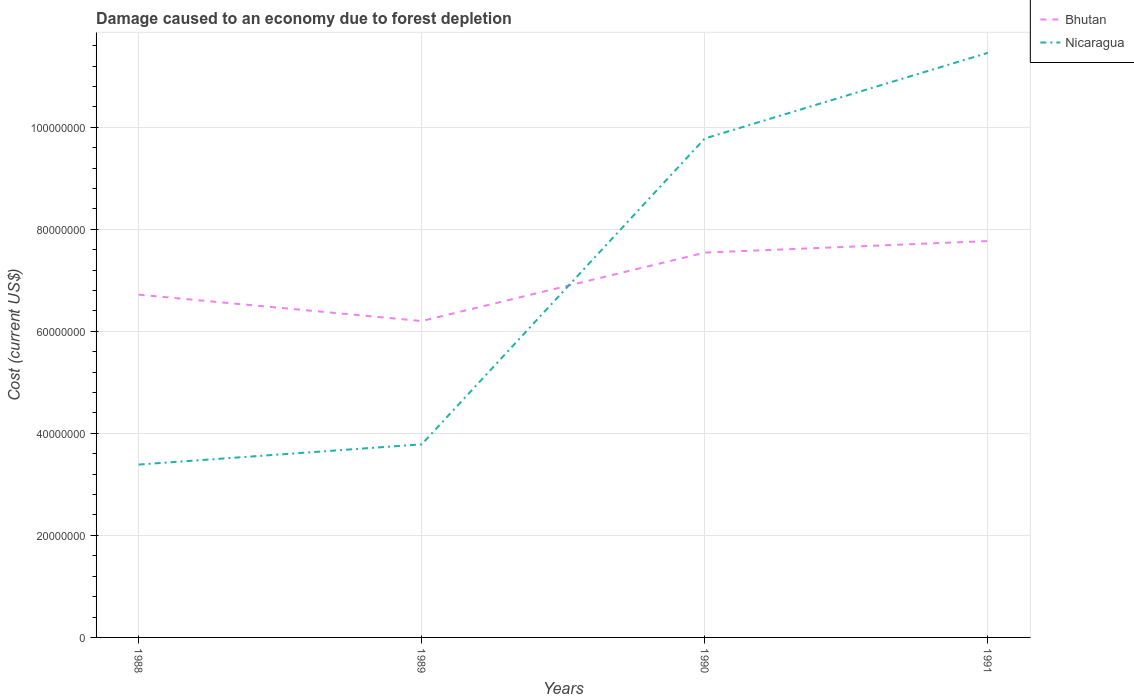How many different coloured lines are there?
Keep it short and to the point. 2. Does the line corresponding to Bhutan intersect with the line corresponding to Nicaragua?
Your response must be concise. Yes. Is the number of lines equal to the number of legend labels?
Your answer should be very brief. Yes. Across all years, what is the maximum cost of damage caused due to forest depletion in Nicaragua?
Offer a very short reply. 3.39e+07. In which year was the cost of damage caused due to forest depletion in Bhutan maximum?
Give a very brief answer. 1989. What is the total cost of damage caused due to forest depletion in Nicaragua in the graph?
Provide a short and direct response. -8.07e+07. What is the difference between the highest and the second highest cost of damage caused due to forest depletion in Nicaragua?
Your answer should be very brief. 8.07e+07. Where does the legend appear in the graph?
Provide a short and direct response. Top right. What is the title of the graph?
Give a very brief answer. Damage caused to an economy due to forest depletion. What is the label or title of the Y-axis?
Give a very brief answer. Cost (current US$). What is the Cost (current US$) of Bhutan in 1988?
Give a very brief answer. 6.72e+07. What is the Cost (current US$) in Nicaragua in 1988?
Your response must be concise. 3.39e+07. What is the Cost (current US$) of Bhutan in 1989?
Keep it short and to the point. 6.20e+07. What is the Cost (current US$) in Nicaragua in 1989?
Offer a very short reply. 3.79e+07. What is the Cost (current US$) in Bhutan in 1990?
Ensure brevity in your answer.  7.54e+07. What is the Cost (current US$) of Nicaragua in 1990?
Make the answer very short. 9.78e+07. What is the Cost (current US$) of Bhutan in 1991?
Your response must be concise. 7.77e+07. What is the Cost (current US$) of Nicaragua in 1991?
Keep it short and to the point. 1.15e+08. Across all years, what is the maximum Cost (current US$) in Bhutan?
Your answer should be compact. 7.77e+07. Across all years, what is the maximum Cost (current US$) in Nicaragua?
Your response must be concise. 1.15e+08. Across all years, what is the minimum Cost (current US$) in Bhutan?
Offer a terse response. 6.20e+07. Across all years, what is the minimum Cost (current US$) of Nicaragua?
Your answer should be very brief. 3.39e+07. What is the total Cost (current US$) of Bhutan in the graph?
Make the answer very short. 2.82e+08. What is the total Cost (current US$) in Nicaragua in the graph?
Make the answer very short. 2.84e+08. What is the difference between the Cost (current US$) in Bhutan in 1988 and that in 1989?
Offer a terse response. 5.17e+06. What is the difference between the Cost (current US$) in Nicaragua in 1988 and that in 1989?
Your response must be concise. -3.97e+06. What is the difference between the Cost (current US$) in Bhutan in 1988 and that in 1990?
Offer a terse response. -8.24e+06. What is the difference between the Cost (current US$) of Nicaragua in 1988 and that in 1990?
Your response must be concise. -6.39e+07. What is the difference between the Cost (current US$) in Bhutan in 1988 and that in 1991?
Offer a terse response. -1.05e+07. What is the difference between the Cost (current US$) in Nicaragua in 1988 and that in 1991?
Make the answer very short. -8.07e+07. What is the difference between the Cost (current US$) in Bhutan in 1989 and that in 1990?
Make the answer very short. -1.34e+07. What is the difference between the Cost (current US$) of Nicaragua in 1989 and that in 1990?
Make the answer very short. -5.99e+07. What is the difference between the Cost (current US$) of Bhutan in 1989 and that in 1991?
Ensure brevity in your answer.  -1.57e+07. What is the difference between the Cost (current US$) in Nicaragua in 1989 and that in 1991?
Keep it short and to the point. -7.67e+07. What is the difference between the Cost (current US$) of Bhutan in 1990 and that in 1991?
Your answer should be very brief. -2.26e+06. What is the difference between the Cost (current US$) of Nicaragua in 1990 and that in 1991?
Provide a succinct answer. -1.68e+07. What is the difference between the Cost (current US$) of Bhutan in 1988 and the Cost (current US$) of Nicaragua in 1989?
Make the answer very short. 2.93e+07. What is the difference between the Cost (current US$) in Bhutan in 1988 and the Cost (current US$) in Nicaragua in 1990?
Provide a short and direct response. -3.06e+07. What is the difference between the Cost (current US$) in Bhutan in 1988 and the Cost (current US$) in Nicaragua in 1991?
Offer a terse response. -4.74e+07. What is the difference between the Cost (current US$) in Bhutan in 1989 and the Cost (current US$) in Nicaragua in 1990?
Provide a succinct answer. -3.58e+07. What is the difference between the Cost (current US$) in Bhutan in 1989 and the Cost (current US$) in Nicaragua in 1991?
Offer a terse response. -5.26e+07. What is the difference between the Cost (current US$) in Bhutan in 1990 and the Cost (current US$) in Nicaragua in 1991?
Your response must be concise. -3.92e+07. What is the average Cost (current US$) in Bhutan per year?
Keep it short and to the point. 7.06e+07. What is the average Cost (current US$) in Nicaragua per year?
Provide a short and direct response. 7.10e+07. In the year 1988, what is the difference between the Cost (current US$) in Bhutan and Cost (current US$) in Nicaragua?
Give a very brief answer. 3.33e+07. In the year 1989, what is the difference between the Cost (current US$) in Bhutan and Cost (current US$) in Nicaragua?
Provide a short and direct response. 2.42e+07. In the year 1990, what is the difference between the Cost (current US$) in Bhutan and Cost (current US$) in Nicaragua?
Provide a short and direct response. -2.24e+07. In the year 1991, what is the difference between the Cost (current US$) in Bhutan and Cost (current US$) in Nicaragua?
Make the answer very short. -3.69e+07. What is the ratio of the Cost (current US$) in Bhutan in 1988 to that in 1989?
Provide a succinct answer. 1.08. What is the ratio of the Cost (current US$) of Nicaragua in 1988 to that in 1989?
Your answer should be compact. 0.9. What is the ratio of the Cost (current US$) in Bhutan in 1988 to that in 1990?
Keep it short and to the point. 0.89. What is the ratio of the Cost (current US$) in Nicaragua in 1988 to that in 1990?
Keep it short and to the point. 0.35. What is the ratio of the Cost (current US$) in Bhutan in 1988 to that in 1991?
Provide a short and direct response. 0.86. What is the ratio of the Cost (current US$) of Nicaragua in 1988 to that in 1991?
Keep it short and to the point. 0.3. What is the ratio of the Cost (current US$) of Bhutan in 1989 to that in 1990?
Give a very brief answer. 0.82. What is the ratio of the Cost (current US$) of Nicaragua in 1989 to that in 1990?
Ensure brevity in your answer.  0.39. What is the ratio of the Cost (current US$) of Bhutan in 1989 to that in 1991?
Keep it short and to the point. 0.8. What is the ratio of the Cost (current US$) of Nicaragua in 1989 to that in 1991?
Provide a succinct answer. 0.33. What is the ratio of the Cost (current US$) of Bhutan in 1990 to that in 1991?
Give a very brief answer. 0.97. What is the ratio of the Cost (current US$) in Nicaragua in 1990 to that in 1991?
Give a very brief answer. 0.85. What is the difference between the highest and the second highest Cost (current US$) in Bhutan?
Your answer should be very brief. 2.26e+06. What is the difference between the highest and the second highest Cost (current US$) of Nicaragua?
Make the answer very short. 1.68e+07. What is the difference between the highest and the lowest Cost (current US$) in Bhutan?
Offer a very short reply. 1.57e+07. What is the difference between the highest and the lowest Cost (current US$) in Nicaragua?
Provide a short and direct response. 8.07e+07. 